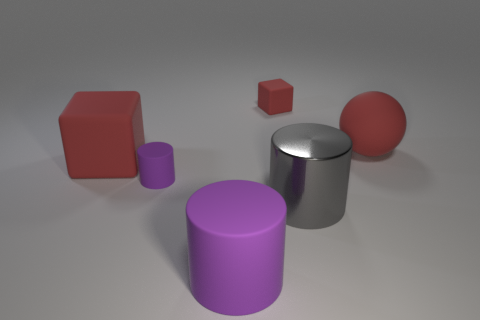There is a gray cylinder that is the same size as the rubber ball; what is it made of?
Provide a short and direct response. Metal. The red rubber thing that is the same size as the red matte ball is what shape?
Ensure brevity in your answer.  Cube. Does the large rubber cube have the same color as the ball?
Make the answer very short. Yes. What shape is the other purple thing that is the same material as the tiny purple thing?
Your answer should be very brief. Cylinder. There is a red cube that is left of the large cylinder that is to the left of the small red cube; what is its size?
Keep it short and to the point. Large. What shape is the big gray thing?
Make the answer very short. Cylinder. What number of large things are gray rubber cylinders or cylinders?
Give a very brief answer. 2. What size is the other rubber object that is the same shape as the small red matte thing?
Your response must be concise. Large. How many small matte things are both in front of the large cube and on the right side of the large purple rubber cylinder?
Provide a short and direct response. 0. Is the shape of the small red thing the same as the purple thing in front of the large metallic thing?
Offer a terse response. No. 